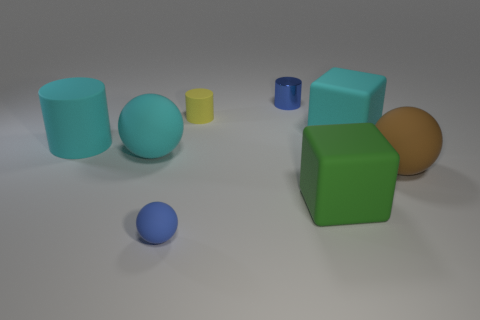Are there any brown spheres that are behind the rubber object that is behind the cyan rubber block?
Offer a very short reply. No. What number of gray things are the same size as the yellow rubber object?
Offer a very short reply. 0. There is a ball that is to the right of the tiny object that is in front of the brown rubber thing; how many large green cubes are behind it?
Your answer should be compact. 0. What number of things are in front of the yellow thing and right of the yellow cylinder?
Provide a succinct answer. 3. Are there any other things of the same color as the tiny matte cylinder?
Your answer should be compact. No. What number of rubber objects are either big spheres or gray cubes?
Offer a very short reply. 2. The cyan thing that is in front of the matte cylinder on the left side of the tiny thing that is in front of the big cylinder is made of what material?
Your answer should be very brief. Rubber. There is a blue thing that is behind the large cyan matte object in front of the big rubber cylinder; what is it made of?
Your response must be concise. Metal. There is a blue thing in front of the green cube; is it the same size as the rubber cylinder that is right of the small sphere?
Your response must be concise. Yes. Are there any other things that are the same material as the large green object?
Your answer should be very brief. Yes. 